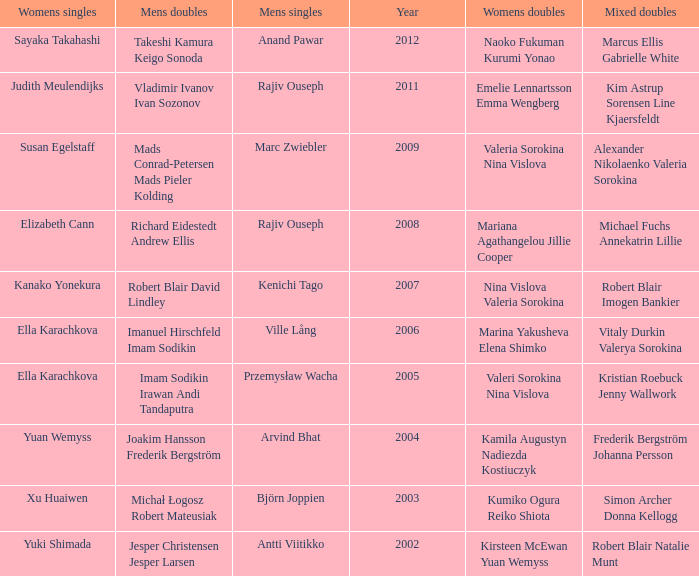What are the womens singles of imam sodikin irawan andi tandaputra? Ella Karachkova. 